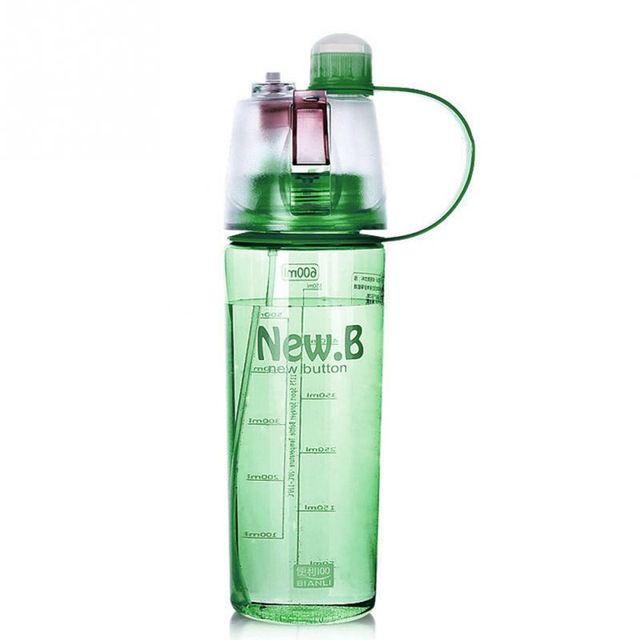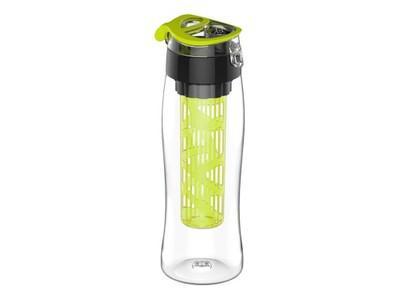The first image is the image on the left, the second image is the image on the right. For the images shown, is this caption "The left and right image contains the same number of water bottles with one being green and see through." true? Answer yes or no. Yes. The first image is the image on the left, the second image is the image on the right. Considering the images on both sides, is "At least one water bottle has a carrying strap hanging loosely down the side." valid? Answer yes or no. No. 